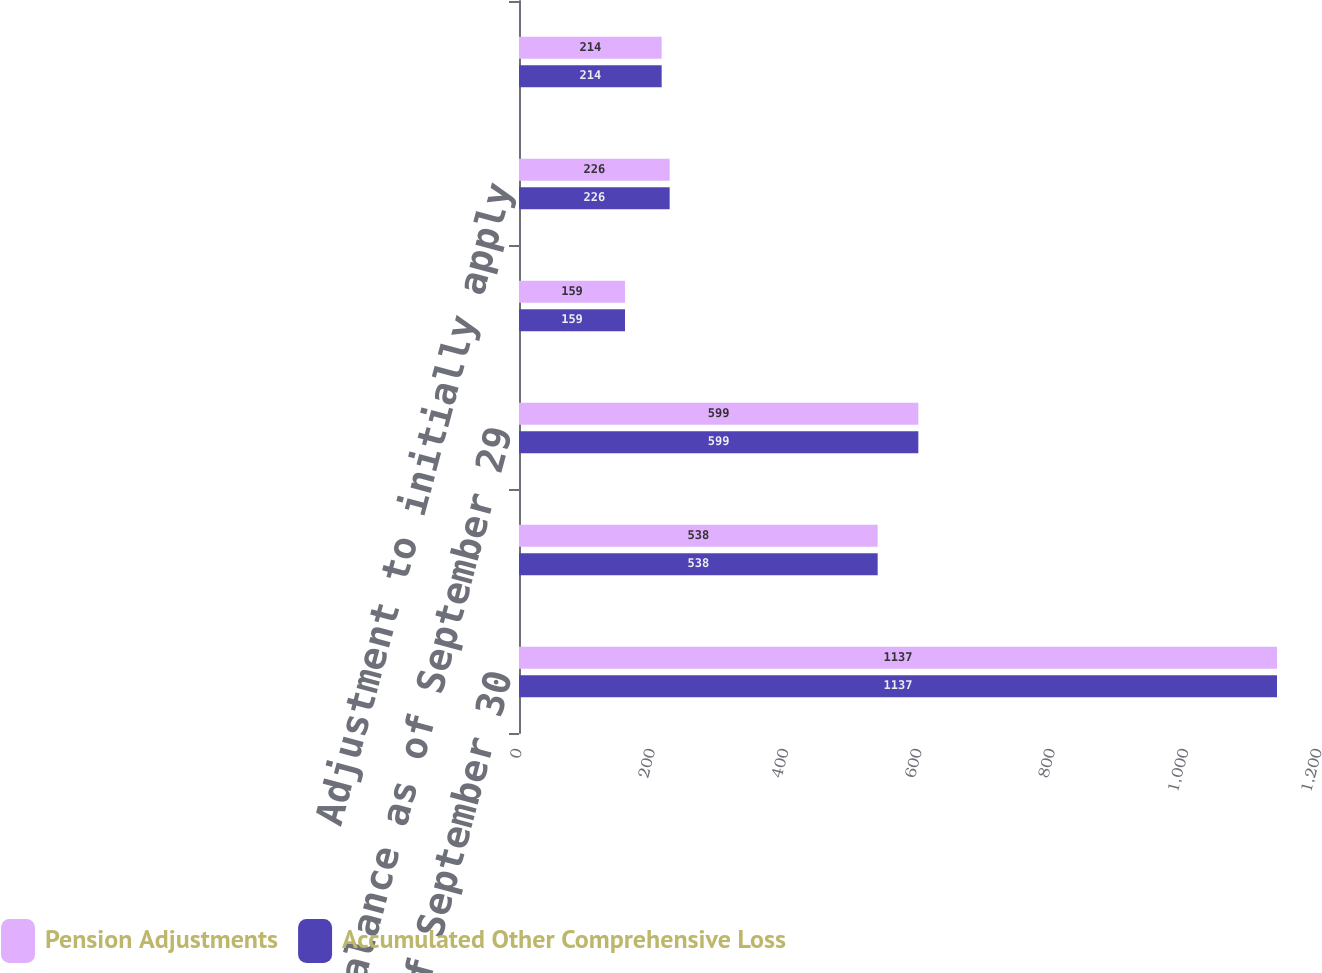<chart> <loc_0><loc_0><loc_500><loc_500><stacked_bar_chart><ecel><fcel>Balance as of September 30<fcel>Change in period<fcel>Balance as of September 29<fcel>Pension adjustment<fcel>Adjustment to initially apply<fcel>Balance as of September 28<nl><fcel>Pension Adjustments<fcel>1137<fcel>538<fcel>599<fcel>159<fcel>226<fcel>214<nl><fcel>Accumulated Other Comprehensive Loss<fcel>1137<fcel>538<fcel>599<fcel>159<fcel>226<fcel>214<nl></chart> 